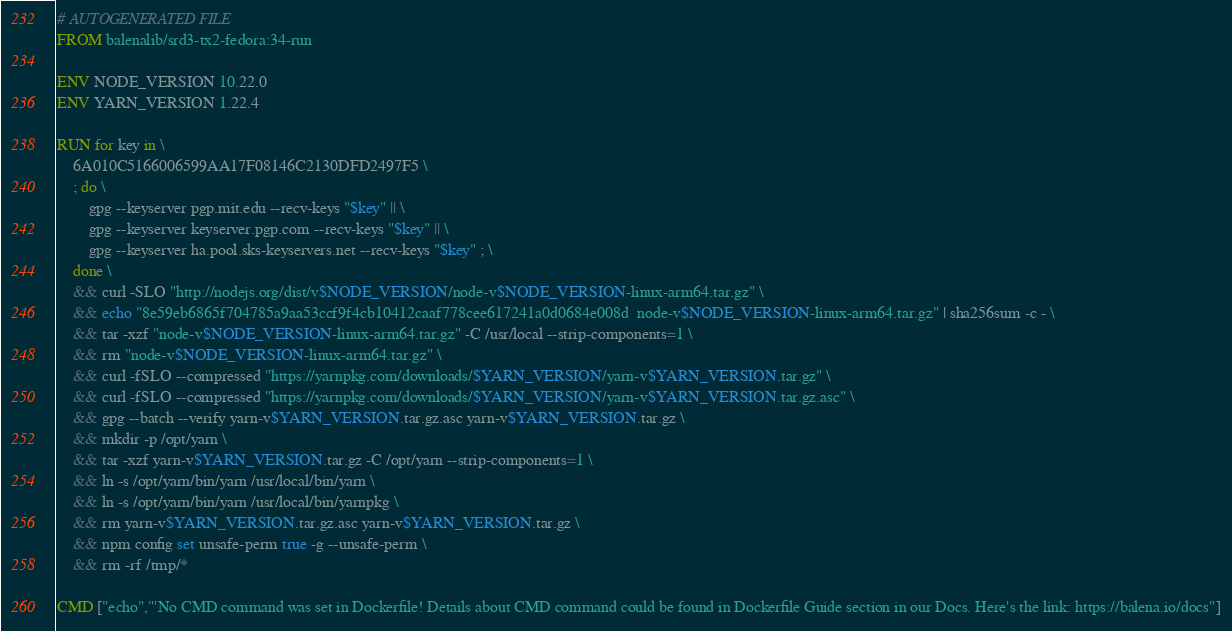Convert code to text. <code><loc_0><loc_0><loc_500><loc_500><_Dockerfile_># AUTOGENERATED FILE
FROM balenalib/srd3-tx2-fedora:34-run

ENV NODE_VERSION 10.22.0
ENV YARN_VERSION 1.22.4

RUN for key in \
	6A010C5166006599AA17F08146C2130DFD2497F5 \
	; do \
		gpg --keyserver pgp.mit.edu --recv-keys "$key" || \
		gpg --keyserver keyserver.pgp.com --recv-keys "$key" || \
		gpg --keyserver ha.pool.sks-keyservers.net --recv-keys "$key" ; \
	done \
	&& curl -SLO "http://nodejs.org/dist/v$NODE_VERSION/node-v$NODE_VERSION-linux-arm64.tar.gz" \
	&& echo "8e59eb6865f704785a9aa53ccf9f4cb10412caaf778cee617241a0d0684e008d  node-v$NODE_VERSION-linux-arm64.tar.gz" | sha256sum -c - \
	&& tar -xzf "node-v$NODE_VERSION-linux-arm64.tar.gz" -C /usr/local --strip-components=1 \
	&& rm "node-v$NODE_VERSION-linux-arm64.tar.gz" \
	&& curl -fSLO --compressed "https://yarnpkg.com/downloads/$YARN_VERSION/yarn-v$YARN_VERSION.tar.gz" \
	&& curl -fSLO --compressed "https://yarnpkg.com/downloads/$YARN_VERSION/yarn-v$YARN_VERSION.tar.gz.asc" \
	&& gpg --batch --verify yarn-v$YARN_VERSION.tar.gz.asc yarn-v$YARN_VERSION.tar.gz \
	&& mkdir -p /opt/yarn \
	&& tar -xzf yarn-v$YARN_VERSION.tar.gz -C /opt/yarn --strip-components=1 \
	&& ln -s /opt/yarn/bin/yarn /usr/local/bin/yarn \
	&& ln -s /opt/yarn/bin/yarn /usr/local/bin/yarnpkg \
	&& rm yarn-v$YARN_VERSION.tar.gz.asc yarn-v$YARN_VERSION.tar.gz \
	&& npm config set unsafe-perm true -g --unsafe-perm \
	&& rm -rf /tmp/*

CMD ["echo","'No CMD command was set in Dockerfile! Details about CMD command could be found in Dockerfile Guide section in our Docs. Here's the link: https://balena.io/docs"]
</code> 